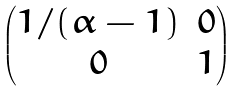Convert formula to latex. <formula><loc_0><loc_0><loc_500><loc_500>\begin{pmatrix} 1 / ( \alpha - 1 ) & 0 \\ 0 & 1 \end{pmatrix}</formula> 